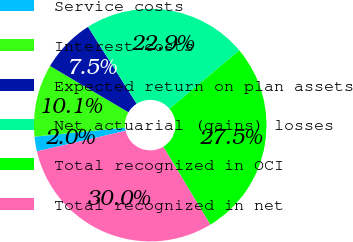<chart> <loc_0><loc_0><loc_500><loc_500><pie_chart><fcel>Service costs<fcel>Interest costs<fcel>Expected return on plan assets<fcel>Net actuarial (gains) losses<fcel>Total recognized in OCI<fcel>Total recognized in net<nl><fcel>2.05%<fcel>10.07%<fcel>7.53%<fcel>22.87%<fcel>27.47%<fcel>30.01%<nl></chart> 